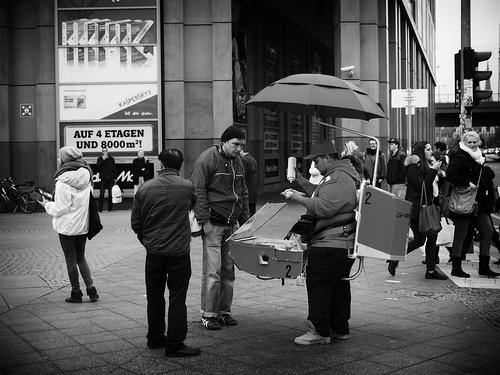Question: what is the vendor selling?
Choices:
A. Hot dogs.
B. Ice cream.
C. Tacos.
D. Frozen bananas.
Answer with the letter. Answer: A Question: when was this picture taken?
Choices:
A. During the day.
B. At night.
C. At sunrise.
D. At twilight.
Answer with the letter. Answer: A Question: what is on the vendors head?
Choices:
A. A helmet.
B. A bandana.
C. Sunglasses.
D. A hat.
Answer with the letter. Answer: D Question: what color is the vendors shirt?
Choices:
A. Black.
B. Grey.
C. White.
D. Yellow.
Answer with the letter. Answer: B Question: who is selling hot dogs?
Choices:
A. Man.
B. Woman.
C. A vendor.
D. Oscar Meyer.
Answer with the letter. Answer: C Question: where was this picture taken?
Choices:
A. Outside a building.
B. In a shopping mall.
C. In an open field.
D. At the beach.
Answer with the letter. Answer: A 